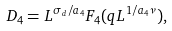<formula> <loc_0><loc_0><loc_500><loc_500>D _ { 4 } = L ^ { \sigma _ { d } / a _ { 4 } } F _ { 4 } ( q L ^ { 1 / a _ { 4 } \nu } ) ,</formula> 